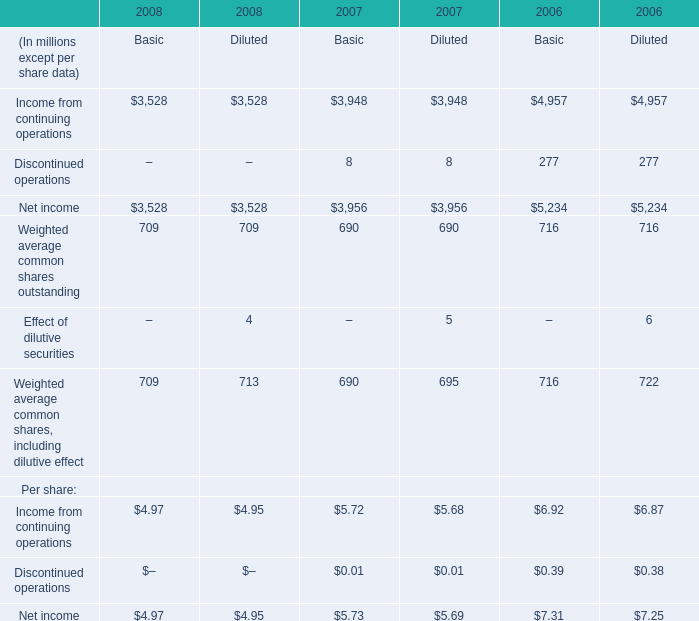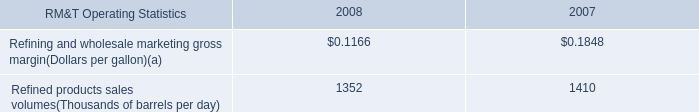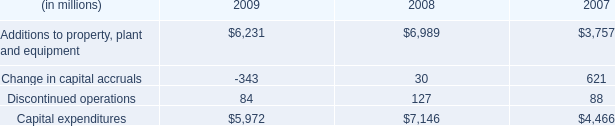What's the average of the Refined products sales volumes(Thousands of barrels per day) in the years where Discontinued operations is greater than 85? 
Computations: ((1352 + 1410) / 2)
Answer: 1381.0. 